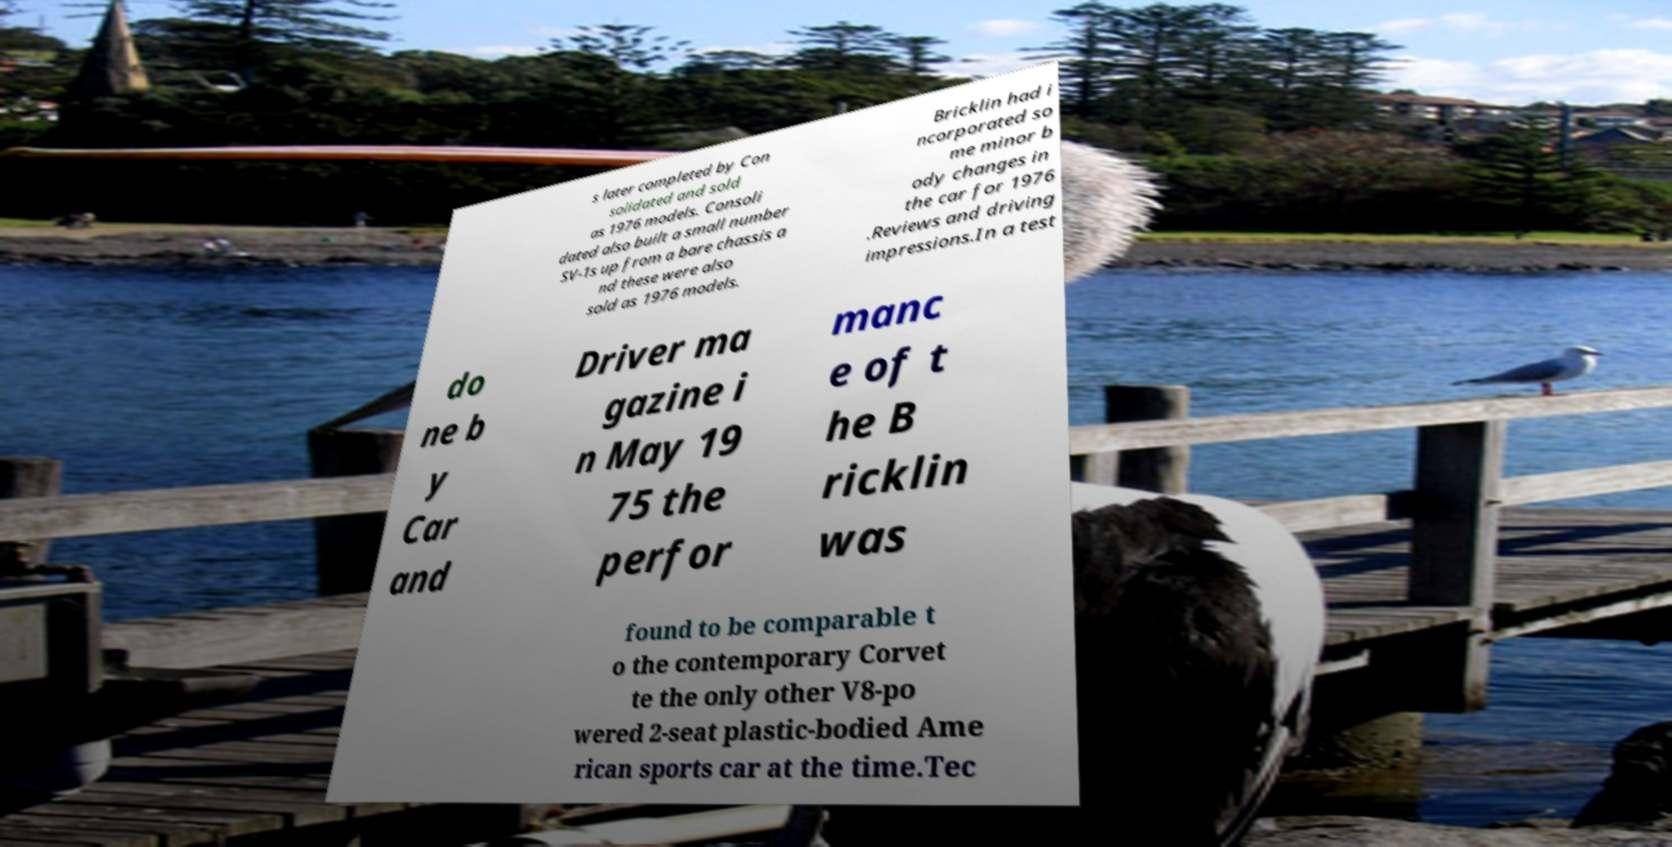For documentation purposes, I need the text within this image transcribed. Could you provide that? s later completed by Con solidated and sold as 1976 models. Consoli dated also built a small number SV-1s up from a bare chassis a nd these were also sold as 1976 models. Bricklin had i ncorporated so me minor b ody changes in the car for 1976 .Reviews and driving impressions.In a test do ne b y Car and Driver ma gazine i n May 19 75 the perfor manc e of t he B ricklin was found to be comparable t o the contemporary Corvet te the only other V8-po wered 2-seat plastic-bodied Ame rican sports car at the time.Tec 